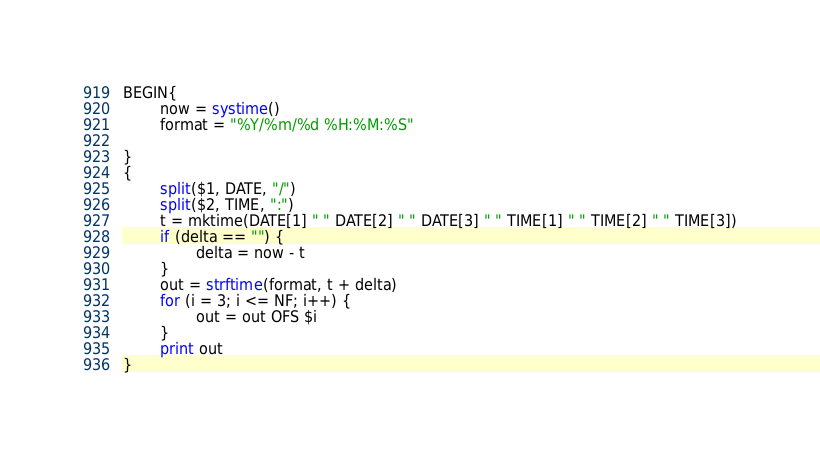Convert code to text. <code><loc_0><loc_0><loc_500><loc_500><_Awk_>BEGIN{
        now = systime()
        format = "%Y/%m/%d %H:%M:%S"
                
}
{
        split($1, DATE, "/")
        split($2, TIME, ":")
        t = mktime(DATE[1] " " DATE[2] " " DATE[3] " " TIME[1] " " TIME[2] " " TIME[3])
        if (delta == "") {
                delta = now - t
        }
        out = strftime(format, t + delta)
        for (i = 3; i <= NF; i++) {
                out = out OFS $i
        }
        print out
}
</code> 